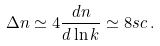<formula> <loc_0><loc_0><loc_500><loc_500>\Delta n \simeq 4 \frac { d n } { d \ln k } \simeq 8 s c \, .</formula> 